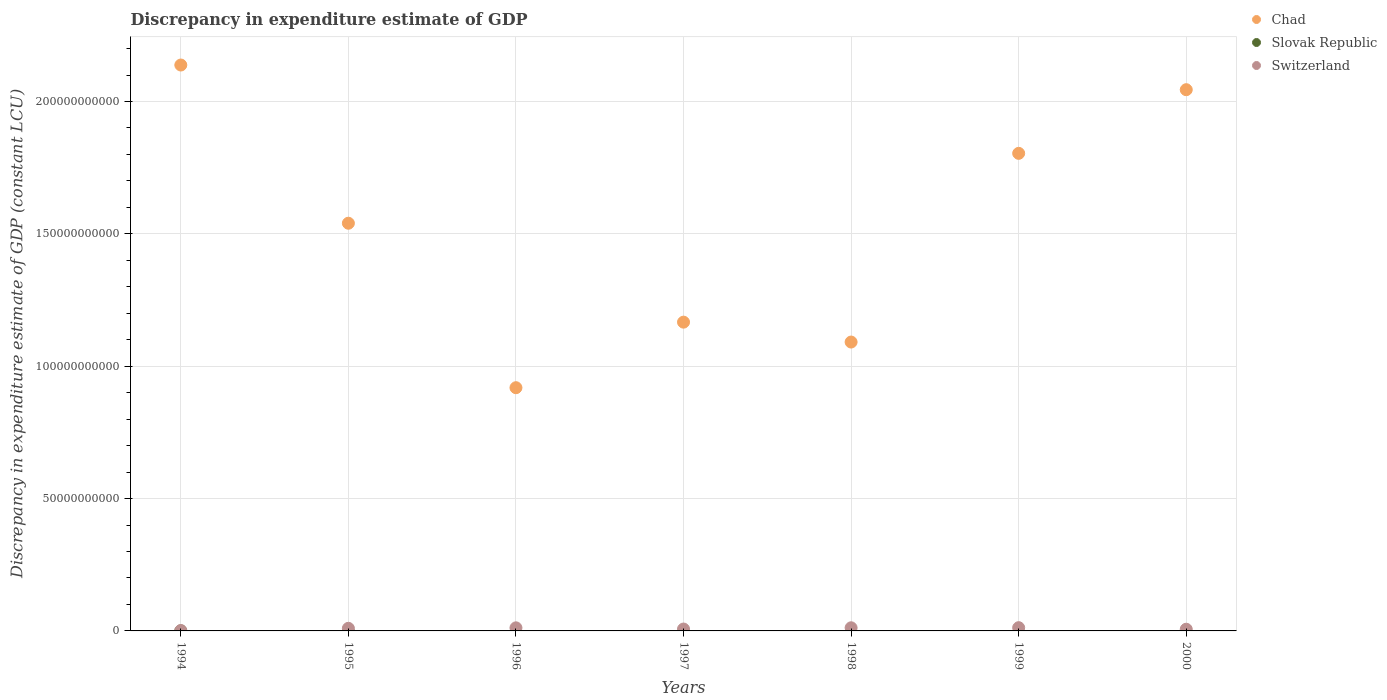How many different coloured dotlines are there?
Ensure brevity in your answer.  3. What is the discrepancy in expenditure estimate of GDP in Slovak Republic in 1995?
Offer a terse response. 0. Across all years, what is the maximum discrepancy in expenditure estimate of GDP in Switzerland?
Provide a succinct answer. 1.22e+09. Across all years, what is the minimum discrepancy in expenditure estimate of GDP in Chad?
Offer a very short reply. 9.19e+1. What is the total discrepancy in expenditure estimate of GDP in Switzerland in the graph?
Ensure brevity in your answer.  6.05e+09. What is the difference between the discrepancy in expenditure estimate of GDP in Switzerland in 1998 and that in 2000?
Offer a terse response. 5.45e+08. What is the difference between the discrepancy in expenditure estimate of GDP in Chad in 1995 and the discrepancy in expenditure estimate of GDP in Switzerland in 1996?
Provide a short and direct response. 1.53e+11. What is the average discrepancy in expenditure estimate of GDP in Chad per year?
Provide a succinct answer. 1.53e+11. In the year 1997, what is the difference between the discrepancy in expenditure estimate of GDP in Switzerland and discrepancy in expenditure estimate of GDP in Chad?
Offer a very short reply. -1.16e+11. What is the ratio of the discrepancy in expenditure estimate of GDP in Chad in 1998 to that in 1999?
Your answer should be very brief. 0.6. Is the discrepancy in expenditure estimate of GDP in Switzerland in 1994 less than that in 2000?
Make the answer very short. Yes. Is the difference between the discrepancy in expenditure estimate of GDP in Switzerland in 1996 and 1999 greater than the difference between the discrepancy in expenditure estimate of GDP in Chad in 1996 and 1999?
Your response must be concise. Yes. What is the difference between the highest and the second highest discrepancy in expenditure estimate of GDP in Switzerland?
Your response must be concise. 3.94e+07. What is the difference between the highest and the lowest discrepancy in expenditure estimate of GDP in Chad?
Your answer should be compact. 1.22e+11. Is the sum of the discrepancy in expenditure estimate of GDP in Chad in 1996 and 2000 greater than the maximum discrepancy in expenditure estimate of GDP in Switzerland across all years?
Your answer should be compact. Yes. Is it the case that in every year, the sum of the discrepancy in expenditure estimate of GDP in Switzerland and discrepancy in expenditure estimate of GDP in Chad  is greater than the discrepancy in expenditure estimate of GDP in Slovak Republic?
Give a very brief answer. Yes. Is the discrepancy in expenditure estimate of GDP in Slovak Republic strictly greater than the discrepancy in expenditure estimate of GDP in Chad over the years?
Ensure brevity in your answer.  No. Is the discrepancy in expenditure estimate of GDP in Switzerland strictly less than the discrepancy in expenditure estimate of GDP in Chad over the years?
Provide a succinct answer. Yes. How many dotlines are there?
Make the answer very short. 3. What is the difference between two consecutive major ticks on the Y-axis?
Your answer should be compact. 5.00e+1. Does the graph contain any zero values?
Ensure brevity in your answer.  Yes. Where does the legend appear in the graph?
Give a very brief answer. Top right. How many legend labels are there?
Give a very brief answer. 3. What is the title of the graph?
Provide a succinct answer. Discrepancy in expenditure estimate of GDP. What is the label or title of the Y-axis?
Offer a very short reply. Discrepancy in expenditure estimate of GDP (constant LCU). What is the Discrepancy in expenditure estimate of GDP (constant LCU) of Chad in 1994?
Offer a very short reply. 2.14e+11. What is the Discrepancy in expenditure estimate of GDP (constant LCU) in Slovak Republic in 1994?
Keep it short and to the point. 6.56e+06. What is the Discrepancy in expenditure estimate of GDP (constant LCU) in Switzerland in 1994?
Your response must be concise. 1.44e+08. What is the Discrepancy in expenditure estimate of GDP (constant LCU) of Chad in 1995?
Make the answer very short. 1.54e+11. What is the Discrepancy in expenditure estimate of GDP (constant LCU) in Switzerland in 1995?
Your answer should be compact. 9.83e+08. What is the Discrepancy in expenditure estimate of GDP (constant LCU) of Chad in 1996?
Offer a very short reply. 9.19e+1. What is the Discrepancy in expenditure estimate of GDP (constant LCU) in Slovak Republic in 1996?
Offer a terse response. 0. What is the Discrepancy in expenditure estimate of GDP (constant LCU) in Switzerland in 1996?
Make the answer very short. 1.17e+09. What is the Discrepancy in expenditure estimate of GDP (constant LCU) in Chad in 1997?
Keep it short and to the point. 1.17e+11. What is the Discrepancy in expenditure estimate of GDP (constant LCU) of Slovak Republic in 1997?
Offer a very short reply. 0. What is the Discrepancy in expenditure estimate of GDP (constant LCU) in Switzerland in 1997?
Ensure brevity in your answer.  7.12e+08. What is the Discrepancy in expenditure estimate of GDP (constant LCU) in Chad in 1998?
Provide a succinct answer. 1.09e+11. What is the Discrepancy in expenditure estimate of GDP (constant LCU) in Switzerland in 1998?
Give a very brief answer. 1.18e+09. What is the Discrepancy in expenditure estimate of GDP (constant LCU) of Chad in 1999?
Offer a terse response. 1.80e+11. What is the Discrepancy in expenditure estimate of GDP (constant LCU) of Switzerland in 1999?
Ensure brevity in your answer.  1.22e+09. What is the Discrepancy in expenditure estimate of GDP (constant LCU) of Chad in 2000?
Ensure brevity in your answer.  2.04e+11. What is the Discrepancy in expenditure estimate of GDP (constant LCU) of Slovak Republic in 2000?
Your response must be concise. 0. What is the Discrepancy in expenditure estimate of GDP (constant LCU) of Switzerland in 2000?
Offer a terse response. 6.40e+08. Across all years, what is the maximum Discrepancy in expenditure estimate of GDP (constant LCU) of Chad?
Offer a terse response. 2.14e+11. Across all years, what is the maximum Discrepancy in expenditure estimate of GDP (constant LCU) in Slovak Republic?
Offer a very short reply. 6.56e+06. Across all years, what is the maximum Discrepancy in expenditure estimate of GDP (constant LCU) of Switzerland?
Ensure brevity in your answer.  1.22e+09. Across all years, what is the minimum Discrepancy in expenditure estimate of GDP (constant LCU) in Chad?
Offer a terse response. 9.19e+1. Across all years, what is the minimum Discrepancy in expenditure estimate of GDP (constant LCU) of Slovak Republic?
Make the answer very short. 0. Across all years, what is the minimum Discrepancy in expenditure estimate of GDP (constant LCU) of Switzerland?
Your answer should be very brief. 1.44e+08. What is the total Discrepancy in expenditure estimate of GDP (constant LCU) in Chad in the graph?
Your answer should be compact. 1.07e+12. What is the total Discrepancy in expenditure estimate of GDP (constant LCU) in Slovak Republic in the graph?
Offer a very short reply. 6.56e+06. What is the total Discrepancy in expenditure estimate of GDP (constant LCU) in Switzerland in the graph?
Provide a short and direct response. 6.05e+09. What is the difference between the Discrepancy in expenditure estimate of GDP (constant LCU) of Chad in 1994 and that in 1995?
Provide a succinct answer. 5.98e+1. What is the difference between the Discrepancy in expenditure estimate of GDP (constant LCU) in Switzerland in 1994 and that in 1995?
Your response must be concise. -8.39e+08. What is the difference between the Discrepancy in expenditure estimate of GDP (constant LCU) in Chad in 1994 and that in 1996?
Provide a succinct answer. 1.22e+11. What is the difference between the Discrepancy in expenditure estimate of GDP (constant LCU) in Switzerland in 1994 and that in 1996?
Give a very brief answer. -1.02e+09. What is the difference between the Discrepancy in expenditure estimate of GDP (constant LCU) in Chad in 1994 and that in 1997?
Offer a very short reply. 9.71e+1. What is the difference between the Discrepancy in expenditure estimate of GDP (constant LCU) in Switzerland in 1994 and that in 1997?
Keep it short and to the point. -5.68e+08. What is the difference between the Discrepancy in expenditure estimate of GDP (constant LCU) in Chad in 1994 and that in 1998?
Provide a short and direct response. 1.05e+11. What is the difference between the Discrepancy in expenditure estimate of GDP (constant LCU) of Switzerland in 1994 and that in 1998?
Offer a terse response. -1.04e+09. What is the difference between the Discrepancy in expenditure estimate of GDP (constant LCU) in Chad in 1994 and that in 1999?
Keep it short and to the point. 3.34e+1. What is the difference between the Discrepancy in expenditure estimate of GDP (constant LCU) of Switzerland in 1994 and that in 1999?
Make the answer very short. -1.08e+09. What is the difference between the Discrepancy in expenditure estimate of GDP (constant LCU) in Chad in 1994 and that in 2000?
Your answer should be compact. 9.32e+09. What is the difference between the Discrepancy in expenditure estimate of GDP (constant LCU) in Switzerland in 1994 and that in 2000?
Offer a terse response. -4.96e+08. What is the difference between the Discrepancy in expenditure estimate of GDP (constant LCU) of Chad in 1995 and that in 1996?
Offer a very short reply. 6.21e+1. What is the difference between the Discrepancy in expenditure estimate of GDP (constant LCU) of Switzerland in 1995 and that in 1996?
Offer a terse response. -1.84e+08. What is the difference between the Discrepancy in expenditure estimate of GDP (constant LCU) of Chad in 1995 and that in 1997?
Your answer should be compact. 3.74e+1. What is the difference between the Discrepancy in expenditure estimate of GDP (constant LCU) of Switzerland in 1995 and that in 1997?
Offer a terse response. 2.71e+08. What is the difference between the Discrepancy in expenditure estimate of GDP (constant LCU) of Chad in 1995 and that in 1998?
Give a very brief answer. 4.49e+1. What is the difference between the Discrepancy in expenditure estimate of GDP (constant LCU) in Switzerland in 1995 and that in 1998?
Make the answer very short. -2.02e+08. What is the difference between the Discrepancy in expenditure estimate of GDP (constant LCU) in Chad in 1995 and that in 1999?
Provide a short and direct response. -2.64e+1. What is the difference between the Discrepancy in expenditure estimate of GDP (constant LCU) of Switzerland in 1995 and that in 1999?
Your answer should be compact. -2.41e+08. What is the difference between the Discrepancy in expenditure estimate of GDP (constant LCU) in Chad in 1995 and that in 2000?
Your answer should be compact. -5.04e+1. What is the difference between the Discrepancy in expenditure estimate of GDP (constant LCU) in Switzerland in 1995 and that in 2000?
Keep it short and to the point. 3.43e+08. What is the difference between the Discrepancy in expenditure estimate of GDP (constant LCU) in Chad in 1996 and that in 1997?
Keep it short and to the point. -2.48e+1. What is the difference between the Discrepancy in expenditure estimate of GDP (constant LCU) of Switzerland in 1996 and that in 1997?
Provide a short and direct response. 4.55e+08. What is the difference between the Discrepancy in expenditure estimate of GDP (constant LCU) of Chad in 1996 and that in 1998?
Provide a short and direct response. -1.72e+1. What is the difference between the Discrepancy in expenditure estimate of GDP (constant LCU) of Switzerland in 1996 and that in 1998?
Give a very brief answer. -1.74e+07. What is the difference between the Discrepancy in expenditure estimate of GDP (constant LCU) in Chad in 1996 and that in 1999?
Your answer should be compact. -8.85e+1. What is the difference between the Discrepancy in expenditure estimate of GDP (constant LCU) in Switzerland in 1996 and that in 1999?
Make the answer very short. -5.68e+07. What is the difference between the Discrepancy in expenditure estimate of GDP (constant LCU) in Chad in 1996 and that in 2000?
Offer a terse response. -1.13e+11. What is the difference between the Discrepancy in expenditure estimate of GDP (constant LCU) in Switzerland in 1996 and that in 2000?
Offer a terse response. 5.27e+08. What is the difference between the Discrepancy in expenditure estimate of GDP (constant LCU) in Chad in 1997 and that in 1998?
Offer a terse response. 7.52e+09. What is the difference between the Discrepancy in expenditure estimate of GDP (constant LCU) in Switzerland in 1997 and that in 1998?
Your response must be concise. -4.72e+08. What is the difference between the Discrepancy in expenditure estimate of GDP (constant LCU) in Chad in 1997 and that in 1999?
Give a very brief answer. -6.38e+1. What is the difference between the Discrepancy in expenditure estimate of GDP (constant LCU) of Switzerland in 1997 and that in 1999?
Provide a succinct answer. -5.12e+08. What is the difference between the Discrepancy in expenditure estimate of GDP (constant LCU) in Chad in 1997 and that in 2000?
Provide a short and direct response. -8.78e+1. What is the difference between the Discrepancy in expenditure estimate of GDP (constant LCU) in Switzerland in 1997 and that in 2000?
Offer a terse response. 7.25e+07. What is the difference between the Discrepancy in expenditure estimate of GDP (constant LCU) of Chad in 1998 and that in 1999?
Keep it short and to the point. -7.13e+1. What is the difference between the Discrepancy in expenditure estimate of GDP (constant LCU) of Switzerland in 1998 and that in 1999?
Your answer should be compact. -3.94e+07. What is the difference between the Discrepancy in expenditure estimate of GDP (constant LCU) in Chad in 1998 and that in 2000?
Make the answer very short. -9.53e+1. What is the difference between the Discrepancy in expenditure estimate of GDP (constant LCU) of Switzerland in 1998 and that in 2000?
Your response must be concise. 5.45e+08. What is the difference between the Discrepancy in expenditure estimate of GDP (constant LCU) in Chad in 1999 and that in 2000?
Offer a very short reply. -2.40e+1. What is the difference between the Discrepancy in expenditure estimate of GDP (constant LCU) of Switzerland in 1999 and that in 2000?
Your answer should be very brief. 5.84e+08. What is the difference between the Discrepancy in expenditure estimate of GDP (constant LCU) in Chad in 1994 and the Discrepancy in expenditure estimate of GDP (constant LCU) in Switzerland in 1995?
Provide a succinct answer. 2.13e+11. What is the difference between the Discrepancy in expenditure estimate of GDP (constant LCU) in Slovak Republic in 1994 and the Discrepancy in expenditure estimate of GDP (constant LCU) in Switzerland in 1995?
Ensure brevity in your answer.  -9.76e+08. What is the difference between the Discrepancy in expenditure estimate of GDP (constant LCU) of Chad in 1994 and the Discrepancy in expenditure estimate of GDP (constant LCU) of Switzerland in 1996?
Provide a short and direct response. 2.13e+11. What is the difference between the Discrepancy in expenditure estimate of GDP (constant LCU) of Slovak Republic in 1994 and the Discrepancy in expenditure estimate of GDP (constant LCU) of Switzerland in 1996?
Your answer should be very brief. -1.16e+09. What is the difference between the Discrepancy in expenditure estimate of GDP (constant LCU) in Chad in 1994 and the Discrepancy in expenditure estimate of GDP (constant LCU) in Switzerland in 1997?
Make the answer very short. 2.13e+11. What is the difference between the Discrepancy in expenditure estimate of GDP (constant LCU) of Slovak Republic in 1994 and the Discrepancy in expenditure estimate of GDP (constant LCU) of Switzerland in 1997?
Your answer should be compact. -7.06e+08. What is the difference between the Discrepancy in expenditure estimate of GDP (constant LCU) in Chad in 1994 and the Discrepancy in expenditure estimate of GDP (constant LCU) in Switzerland in 1998?
Your answer should be compact. 2.13e+11. What is the difference between the Discrepancy in expenditure estimate of GDP (constant LCU) in Slovak Republic in 1994 and the Discrepancy in expenditure estimate of GDP (constant LCU) in Switzerland in 1998?
Give a very brief answer. -1.18e+09. What is the difference between the Discrepancy in expenditure estimate of GDP (constant LCU) of Chad in 1994 and the Discrepancy in expenditure estimate of GDP (constant LCU) of Switzerland in 1999?
Your response must be concise. 2.13e+11. What is the difference between the Discrepancy in expenditure estimate of GDP (constant LCU) of Slovak Republic in 1994 and the Discrepancy in expenditure estimate of GDP (constant LCU) of Switzerland in 1999?
Offer a terse response. -1.22e+09. What is the difference between the Discrepancy in expenditure estimate of GDP (constant LCU) in Chad in 1994 and the Discrepancy in expenditure estimate of GDP (constant LCU) in Switzerland in 2000?
Ensure brevity in your answer.  2.13e+11. What is the difference between the Discrepancy in expenditure estimate of GDP (constant LCU) of Slovak Republic in 1994 and the Discrepancy in expenditure estimate of GDP (constant LCU) of Switzerland in 2000?
Give a very brief answer. -6.33e+08. What is the difference between the Discrepancy in expenditure estimate of GDP (constant LCU) in Chad in 1995 and the Discrepancy in expenditure estimate of GDP (constant LCU) in Switzerland in 1996?
Offer a terse response. 1.53e+11. What is the difference between the Discrepancy in expenditure estimate of GDP (constant LCU) of Chad in 1995 and the Discrepancy in expenditure estimate of GDP (constant LCU) of Switzerland in 1997?
Keep it short and to the point. 1.53e+11. What is the difference between the Discrepancy in expenditure estimate of GDP (constant LCU) in Chad in 1995 and the Discrepancy in expenditure estimate of GDP (constant LCU) in Switzerland in 1998?
Offer a terse response. 1.53e+11. What is the difference between the Discrepancy in expenditure estimate of GDP (constant LCU) in Chad in 1995 and the Discrepancy in expenditure estimate of GDP (constant LCU) in Switzerland in 1999?
Offer a terse response. 1.53e+11. What is the difference between the Discrepancy in expenditure estimate of GDP (constant LCU) of Chad in 1995 and the Discrepancy in expenditure estimate of GDP (constant LCU) of Switzerland in 2000?
Offer a very short reply. 1.53e+11. What is the difference between the Discrepancy in expenditure estimate of GDP (constant LCU) in Chad in 1996 and the Discrepancy in expenditure estimate of GDP (constant LCU) in Switzerland in 1997?
Ensure brevity in your answer.  9.12e+1. What is the difference between the Discrepancy in expenditure estimate of GDP (constant LCU) of Chad in 1996 and the Discrepancy in expenditure estimate of GDP (constant LCU) of Switzerland in 1998?
Your response must be concise. 9.07e+1. What is the difference between the Discrepancy in expenditure estimate of GDP (constant LCU) of Chad in 1996 and the Discrepancy in expenditure estimate of GDP (constant LCU) of Switzerland in 1999?
Provide a short and direct response. 9.07e+1. What is the difference between the Discrepancy in expenditure estimate of GDP (constant LCU) in Chad in 1996 and the Discrepancy in expenditure estimate of GDP (constant LCU) in Switzerland in 2000?
Make the answer very short. 9.12e+1. What is the difference between the Discrepancy in expenditure estimate of GDP (constant LCU) of Chad in 1997 and the Discrepancy in expenditure estimate of GDP (constant LCU) of Switzerland in 1998?
Keep it short and to the point. 1.15e+11. What is the difference between the Discrepancy in expenditure estimate of GDP (constant LCU) in Chad in 1997 and the Discrepancy in expenditure estimate of GDP (constant LCU) in Switzerland in 1999?
Offer a very short reply. 1.15e+11. What is the difference between the Discrepancy in expenditure estimate of GDP (constant LCU) in Chad in 1997 and the Discrepancy in expenditure estimate of GDP (constant LCU) in Switzerland in 2000?
Provide a short and direct response. 1.16e+11. What is the difference between the Discrepancy in expenditure estimate of GDP (constant LCU) in Chad in 1998 and the Discrepancy in expenditure estimate of GDP (constant LCU) in Switzerland in 1999?
Offer a terse response. 1.08e+11. What is the difference between the Discrepancy in expenditure estimate of GDP (constant LCU) in Chad in 1998 and the Discrepancy in expenditure estimate of GDP (constant LCU) in Switzerland in 2000?
Provide a short and direct response. 1.08e+11. What is the difference between the Discrepancy in expenditure estimate of GDP (constant LCU) of Chad in 1999 and the Discrepancy in expenditure estimate of GDP (constant LCU) of Switzerland in 2000?
Keep it short and to the point. 1.80e+11. What is the average Discrepancy in expenditure estimate of GDP (constant LCU) of Chad per year?
Provide a succinct answer. 1.53e+11. What is the average Discrepancy in expenditure estimate of GDP (constant LCU) of Slovak Republic per year?
Provide a short and direct response. 9.37e+05. What is the average Discrepancy in expenditure estimate of GDP (constant LCU) in Switzerland per year?
Provide a short and direct response. 8.65e+08. In the year 1994, what is the difference between the Discrepancy in expenditure estimate of GDP (constant LCU) of Chad and Discrepancy in expenditure estimate of GDP (constant LCU) of Slovak Republic?
Keep it short and to the point. 2.14e+11. In the year 1994, what is the difference between the Discrepancy in expenditure estimate of GDP (constant LCU) of Chad and Discrepancy in expenditure estimate of GDP (constant LCU) of Switzerland?
Offer a very short reply. 2.14e+11. In the year 1994, what is the difference between the Discrepancy in expenditure estimate of GDP (constant LCU) of Slovak Republic and Discrepancy in expenditure estimate of GDP (constant LCU) of Switzerland?
Offer a terse response. -1.37e+08. In the year 1995, what is the difference between the Discrepancy in expenditure estimate of GDP (constant LCU) of Chad and Discrepancy in expenditure estimate of GDP (constant LCU) of Switzerland?
Make the answer very short. 1.53e+11. In the year 1996, what is the difference between the Discrepancy in expenditure estimate of GDP (constant LCU) in Chad and Discrepancy in expenditure estimate of GDP (constant LCU) in Switzerland?
Ensure brevity in your answer.  9.07e+1. In the year 1997, what is the difference between the Discrepancy in expenditure estimate of GDP (constant LCU) in Chad and Discrepancy in expenditure estimate of GDP (constant LCU) in Switzerland?
Offer a terse response. 1.16e+11. In the year 1998, what is the difference between the Discrepancy in expenditure estimate of GDP (constant LCU) of Chad and Discrepancy in expenditure estimate of GDP (constant LCU) of Switzerland?
Offer a terse response. 1.08e+11. In the year 1999, what is the difference between the Discrepancy in expenditure estimate of GDP (constant LCU) of Chad and Discrepancy in expenditure estimate of GDP (constant LCU) of Switzerland?
Your response must be concise. 1.79e+11. In the year 2000, what is the difference between the Discrepancy in expenditure estimate of GDP (constant LCU) of Chad and Discrepancy in expenditure estimate of GDP (constant LCU) of Switzerland?
Your answer should be compact. 2.04e+11. What is the ratio of the Discrepancy in expenditure estimate of GDP (constant LCU) in Chad in 1994 to that in 1995?
Offer a very short reply. 1.39. What is the ratio of the Discrepancy in expenditure estimate of GDP (constant LCU) in Switzerland in 1994 to that in 1995?
Provide a succinct answer. 0.15. What is the ratio of the Discrepancy in expenditure estimate of GDP (constant LCU) of Chad in 1994 to that in 1996?
Your answer should be very brief. 2.33. What is the ratio of the Discrepancy in expenditure estimate of GDP (constant LCU) in Switzerland in 1994 to that in 1996?
Your response must be concise. 0.12. What is the ratio of the Discrepancy in expenditure estimate of GDP (constant LCU) in Chad in 1994 to that in 1997?
Keep it short and to the point. 1.83. What is the ratio of the Discrepancy in expenditure estimate of GDP (constant LCU) of Switzerland in 1994 to that in 1997?
Keep it short and to the point. 0.2. What is the ratio of the Discrepancy in expenditure estimate of GDP (constant LCU) in Chad in 1994 to that in 1998?
Give a very brief answer. 1.96. What is the ratio of the Discrepancy in expenditure estimate of GDP (constant LCU) in Switzerland in 1994 to that in 1998?
Your answer should be very brief. 0.12. What is the ratio of the Discrepancy in expenditure estimate of GDP (constant LCU) of Chad in 1994 to that in 1999?
Your answer should be compact. 1.18. What is the ratio of the Discrepancy in expenditure estimate of GDP (constant LCU) of Switzerland in 1994 to that in 1999?
Give a very brief answer. 0.12. What is the ratio of the Discrepancy in expenditure estimate of GDP (constant LCU) of Chad in 1994 to that in 2000?
Make the answer very short. 1.05. What is the ratio of the Discrepancy in expenditure estimate of GDP (constant LCU) in Switzerland in 1994 to that in 2000?
Give a very brief answer. 0.23. What is the ratio of the Discrepancy in expenditure estimate of GDP (constant LCU) of Chad in 1995 to that in 1996?
Make the answer very short. 1.68. What is the ratio of the Discrepancy in expenditure estimate of GDP (constant LCU) of Switzerland in 1995 to that in 1996?
Give a very brief answer. 0.84. What is the ratio of the Discrepancy in expenditure estimate of GDP (constant LCU) of Chad in 1995 to that in 1997?
Provide a succinct answer. 1.32. What is the ratio of the Discrepancy in expenditure estimate of GDP (constant LCU) of Switzerland in 1995 to that in 1997?
Make the answer very short. 1.38. What is the ratio of the Discrepancy in expenditure estimate of GDP (constant LCU) of Chad in 1995 to that in 1998?
Ensure brevity in your answer.  1.41. What is the ratio of the Discrepancy in expenditure estimate of GDP (constant LCU) of Switzerland in 1995 to that in 1998?
Offer a very short reply. 0.83. What is the ratio of the Discrepancy in expenditure estimate of GDP (constant LCU) of Chad in 1995 to that in 1999?
Make the answer very short. 0.85. What is the ratio of the Discrepancy in expenditure estimate of GDP (constant LCU) of Switzerland in 1995 to that in 1999?
Ensure brevity in your answer.  0.8. What is the ratio of the Discrepancy in expenditure estimate of GDP (constant LCU) of Chad in 1995 to that in 2000?
Provide a short and direct response. 0.75. What is the ratio of the Discrepancy in expenditure estimate of GDP (constant LCU) of Switzerland in 1995 to that in 2000?
Your answer should be compact. 1.54. What is the ratio of the Discrepancy in expenditure estimate of GDP (constant LCU) in Chad in 1996 to that in 1997?
Provide a short and direct response. 0.79. What is the ratio of the Discrepancy in expenditure estimate of GDP (constant LCU) of Switzerland in 1996 to that in 1997?
Ensure brevity in your answer.  1.64. What is the ratio of the Discrepancy in expenditure estimate of GDP (constant LCU) of Chad in 1996 to that in 1998?
Ensure brevity in your answer.  0.84. What is the ratio of the Discrepancy in expenditure estimate of GDP (constant LCU) of Chad in 1996 to that in 1999?
Offer a terse response. 0.51. What is the ratio of the Discrepancy in expenditure estimate of GDP (constant LCU) of Switzerland in 1996 to that in 1999?
Your response must be concise. 0.95. What is the ratio of the Discrepancy in expenditure estimate of GDP (constant LCU) in Chad in 1996 to that in 2000?
Your answer should be compact. 0.45. What is the ratio of the Discrepancy in expenditure estimate of GDP (constant LCU) in Switzerland in 1996 to that in 2000?
Your response must be concise. 1.82. What is the ratio of the Discrepancy in expenditure estimate of GDP (constant LCU) of Chad in 1997 to that in 1998?
Keep it short and to the point. 1.07. What is the ratio of the Discrepancy in expenditure estimate of GDP (constant LCU) of Switzerland in 1997 to that in 1998?
Keep it short and to the point. 0.6. What is the ratio of the Discrepancy in expenditure estimate of GDP (constant LCU) of Chad in 1997 to that in 1999?
Make the answer very short. 0.65. What is the ratio of the Discrepancy in expenditure estimate of GDP (constant LCU) in Switzerland in 1997 to that in 1999?
Provide a short and direct response. 0.58. What is the ratio of the Discrepancy in expenditure estimate of GDP (constant LCU) in Chad in 1997 to that in 2000?
Your response must be concise. 0.57. What is the ratio of the Discrepancy in expenditure estimate of GDP (constant LCU) of Switzerland in 1997 to that in 2000?
Offer a terse response. 1.11. What is the ratio of the Discrepancy in expenditure estimate of GDP (constant LCU) of Chad in 1998 to that in 1999?
Offer a very short reply. 0.6. What is the ratio of the Discrepancy in expenditure estimate of GDP (constant LCU) in Switzerland in 1998 to that in 1999?
Your answer should be compact. 0.97. What is the ratio of the Discrepancy in expenditure estimate of GDP (constant LCU) of Chad in 1998 to that in 2000?
Keep it short and to the point. 0.53. What is the ratio of the Discrepancy in expenditure estimate of GDP (constant LCU) in Switzerland in 1998 to that in 2000?
Ensure brevity in your answer.  1.85. What is the ratio of the Discrepancy in expenditure estimate of GDP (constant LCU) of Chad in 1999 to that in 2000?
Offer a very short reply. 0.88. What is the ratio of the Discrepancy in expenditure estimate of GDP (constant LCU) of Switzerland in 1999 to that in 2000?
Keep it short and to the point. 1.91. What is the difference between the highest and the second highest Discrepancy in expenditure estimate of GDP (constant LCU) of Chad?
Keep it short and to the point. 9.32e+09. What is the difference between the highest and the second highest Discrepancy in expenditure estimate of GDP (constant LCU) in Switzerland?
Ensure brevity in your answer.  3.94e+07. What is the difference between the highest and the lowest Discrepancy in expenditure estimate of GDP (constant LCU) in Chad?
Your response must be concise. 1.22e+11. What is the difference between the highest and the lowest Discrepancy in expenditure estimate of GDP (constant LCU) of Slovak Republic?
Keep it short and to the point. 6.56e+06. What is the difference between the highest and the lowest Discrepancy in expenditure estimate of GDP (constant LCU) of Switzerland?
Make the answer very short. 1.08e+09. 